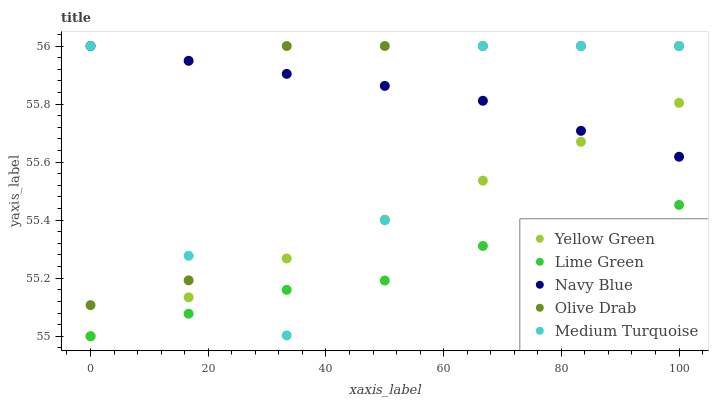Does Lime Green have the minimum area under the curve?
Answer yes or no. Yes. Does Navy Blue have the maximum area under the curve?
Answer yes or no. Yes. Does Medium Turquoise have the minimum area under the curve?
Answer yes or no. No. Does Medium Turquoise have the maximum area under the curve?
Answer yes or no. No. Is Yellow Green the smoothest?
Answer yes or no. Yes. Is Medium Turquoise the roughest?
Answer yes or no. Yes. Is Lime Green the smoothest?
Answer yes or no. No. Is Lime Green the roughest?
Answer yes or no. No. Does Lime Green have the lowest value?
Answer yes or no. Yes. Does Medium Turquoise have the lowest value?
Answer yes or no. No. Does Olive Drab have the highest value?
Answer yes or no. Yes. Does Lime Green have the highest value?
Answer yes or no. No. Is Lime Green less than Navy Blue?
Answer yes or no. Yes. Is Olive Drab greater than Lime Green?
Answer yes or no. Yes. Does Medium Turquoise intersect Navy Blue?
Answer yes or no. Yes. Is Medium Turquoise less than Navy Blue?
Answer yes or no. No. Is Medium Turquoise greater than Navy Blue?
Answer yes or no. No. Does Lime Green intersect Navy Blue?
Answer yes or no. No. 